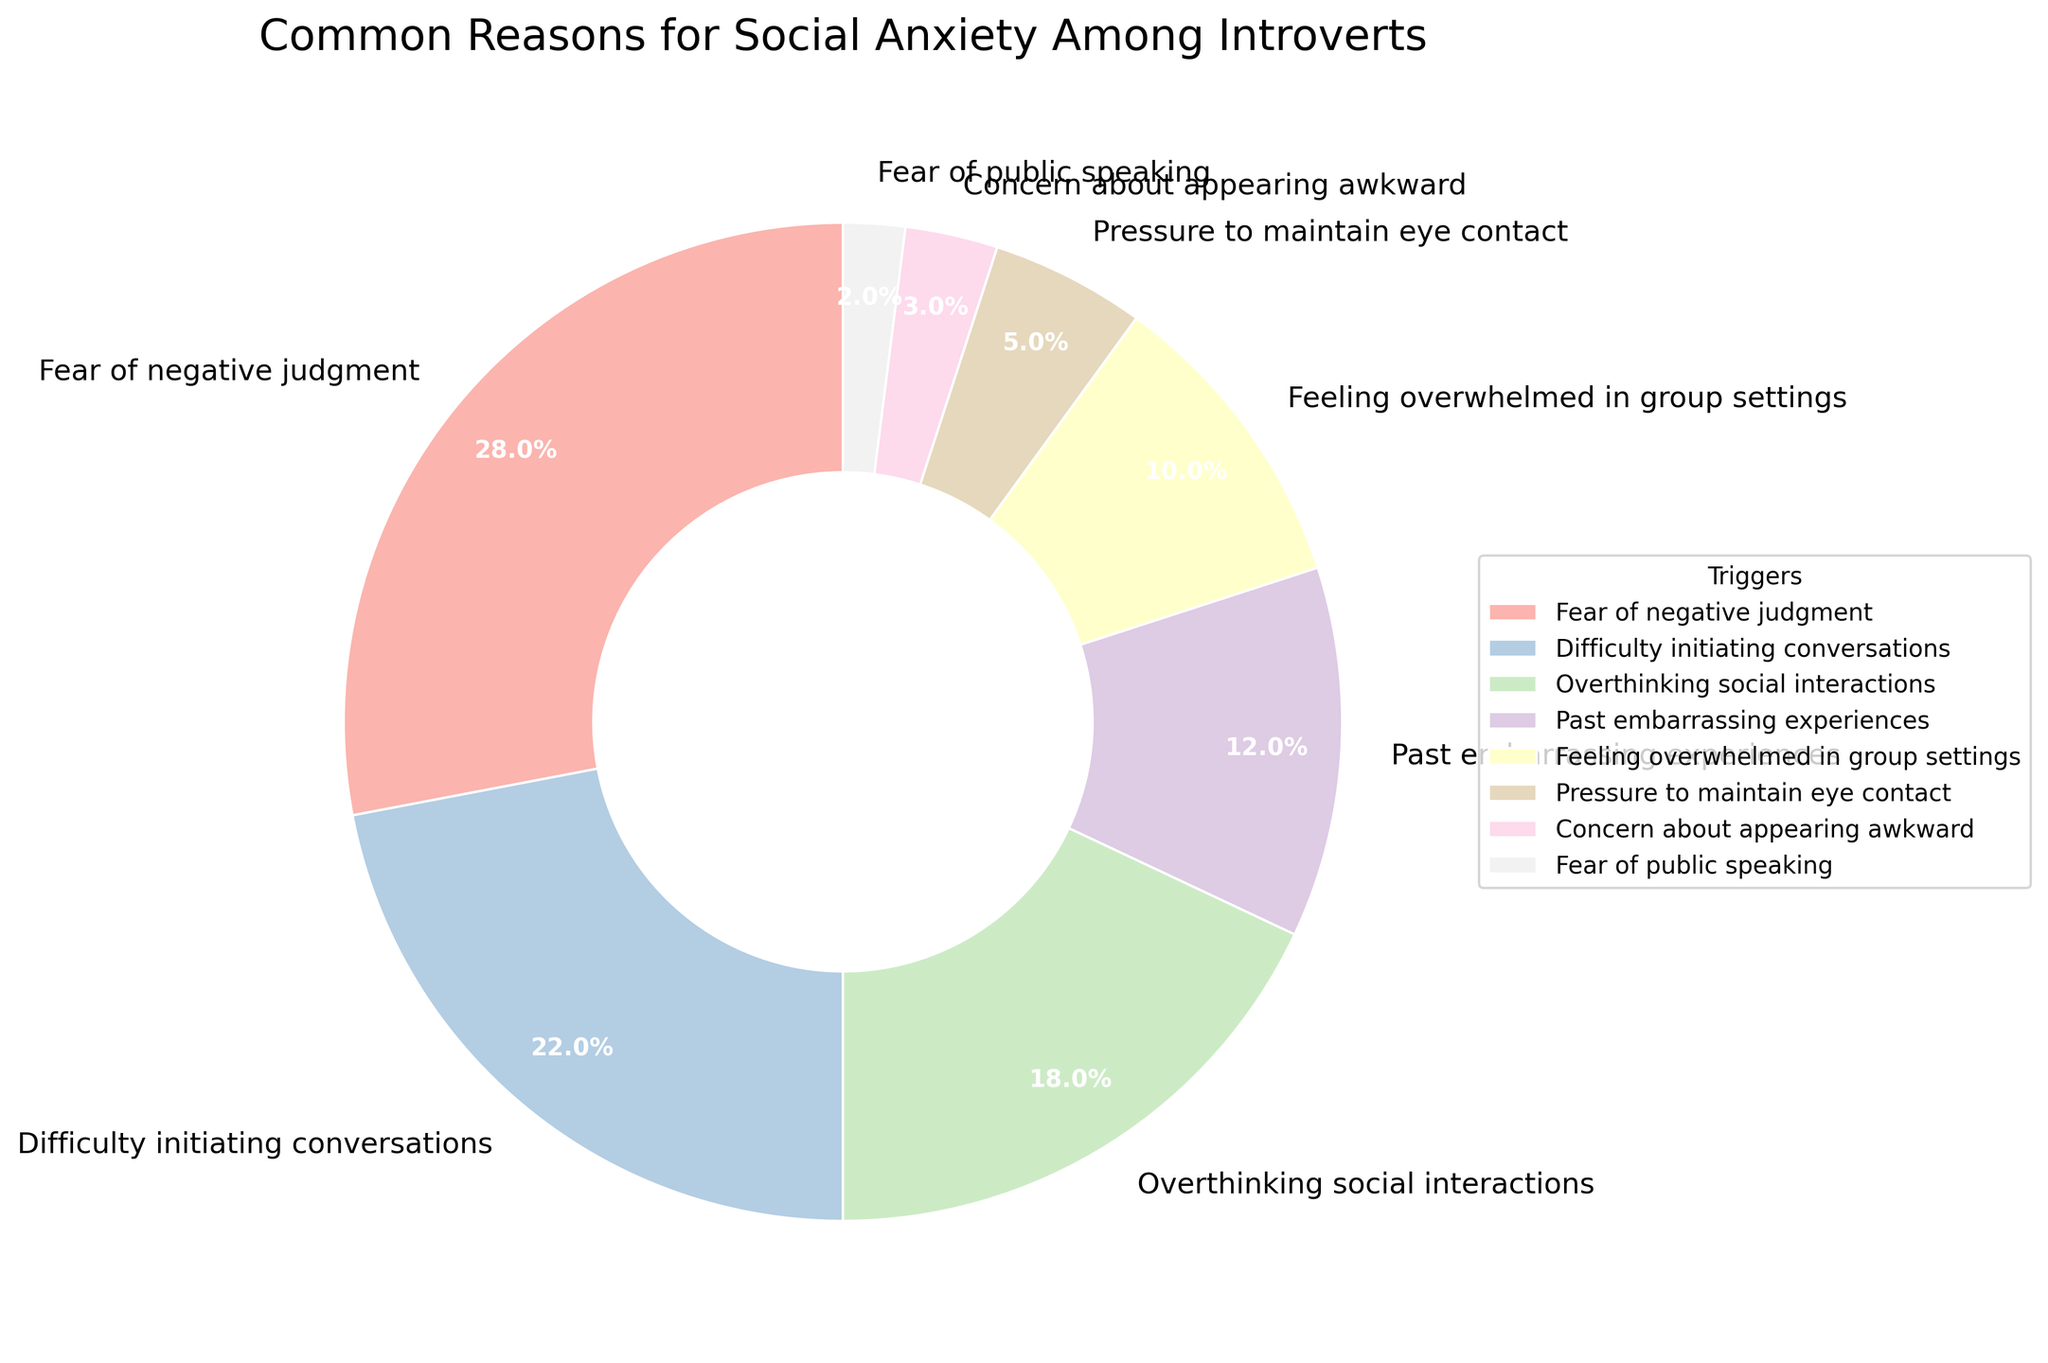Which trigger has the highest percentage? The pie chart shows the proportion of each trigger. "Fear of negative judgment" has the largest section.
Answer: Fear of negative judgment What is the combined percentage of "Fear of public speaking" and "Concern about appearing awkward"? To find the combined percentage, we add 2% (Fear of public speaking) and 3% (Concern about appearing awkward).
Answer: 5% Which trigger has a smaller percentage, "Past embarrassing experiences" or "Feeling overwhelmed in group settings"? Comparing the two segments, "Past embarrassing experiences" is 12%, and "Feeling overwhelmed in group settings" is 10%.
Answer: Feeling overwhelmed in group settings What is the percentage difference between "Difficulty initiating conversations" and "Overthinking social interactions"? "Difficulty initiating conversations" is 22% and "Overthinking social interactions" is 18%. The difference is 22% - 18% = 4%.
Answer: 4% How much greater is the percentage of "Fear of negative judgment" compared to "Pressure to maintain eye contact"? "Fear of negative judgment" is 28% and "Pressure to maintain eye contact" is 5%. The difference is 28% - 5% = 23%.
Answer: 23% What is the total percentage of the top three triggers? The top three triggers are "Fear of negative judgment" (28%), "Difficulty initiating conversations" (22%), and "Overthinking social interactions" (18%). The total is 28% + 22% + 18% = 68%.
Answer: 68% Which trigger has the smallest section in the pie chart? The trigger with the smallest section in the pie chart is "Fear of public speaking" with 2%.
Answer: Fear of public speaking Is "Concern about appearing awkward" under 5%? The pie chart shows that "Concern about appearing awkward" is 3%, which is indeed under 5%.
Answer: Yes 